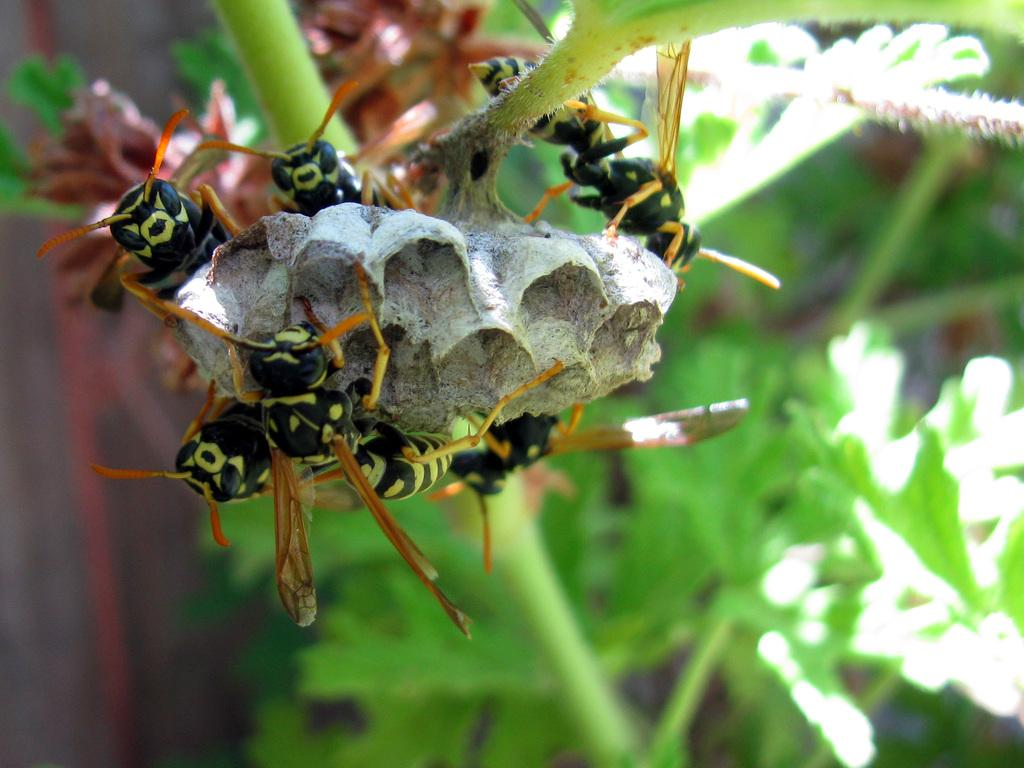What is present in the image? There is a plant in the image. What can be observed about the plant? The plant has a flower. Are there any other living organisms present on the flower? Yes, there are insects on the flower. What type of noise can be heard coming from the band in the image? There is no band present in the image, so it's not possible to determine what, if any, noise might be heard. 